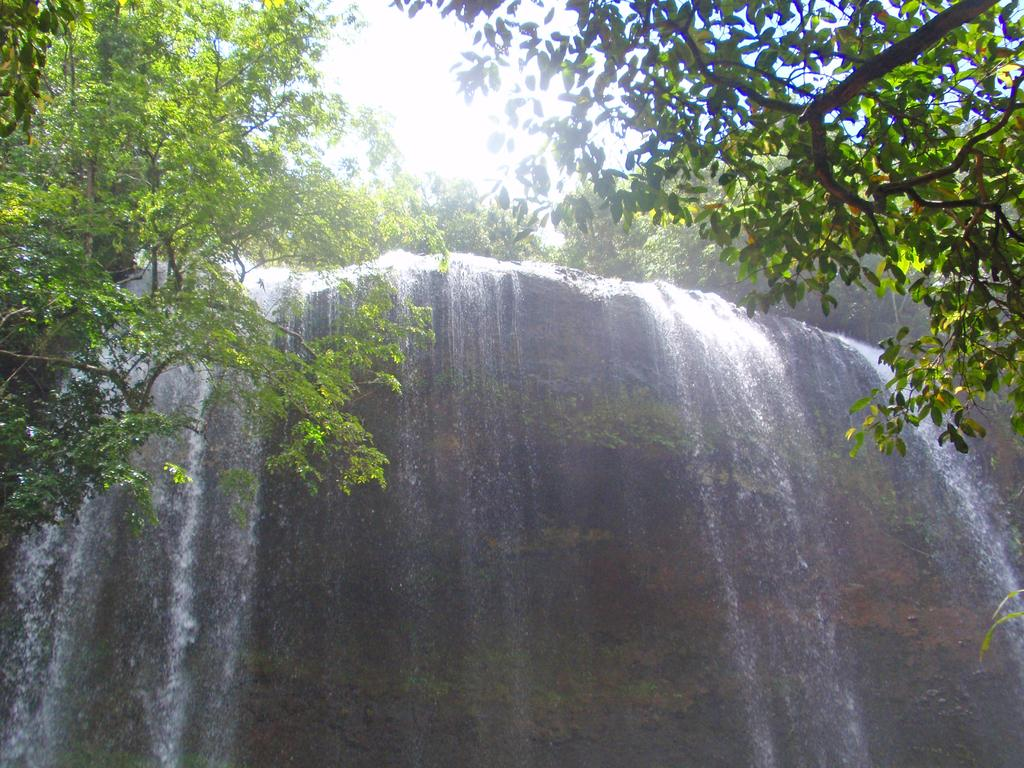What is the main subject of the picture? The main subject of the picture is a waterfall. What can be seen in the background of the picture? There are trees and the sky visible in the background of the picture. What type of key is used to unlock the design of the waterfall in the image? There is no key or design present in the image; it is a natural waterfall with no locks or hidden designs. 